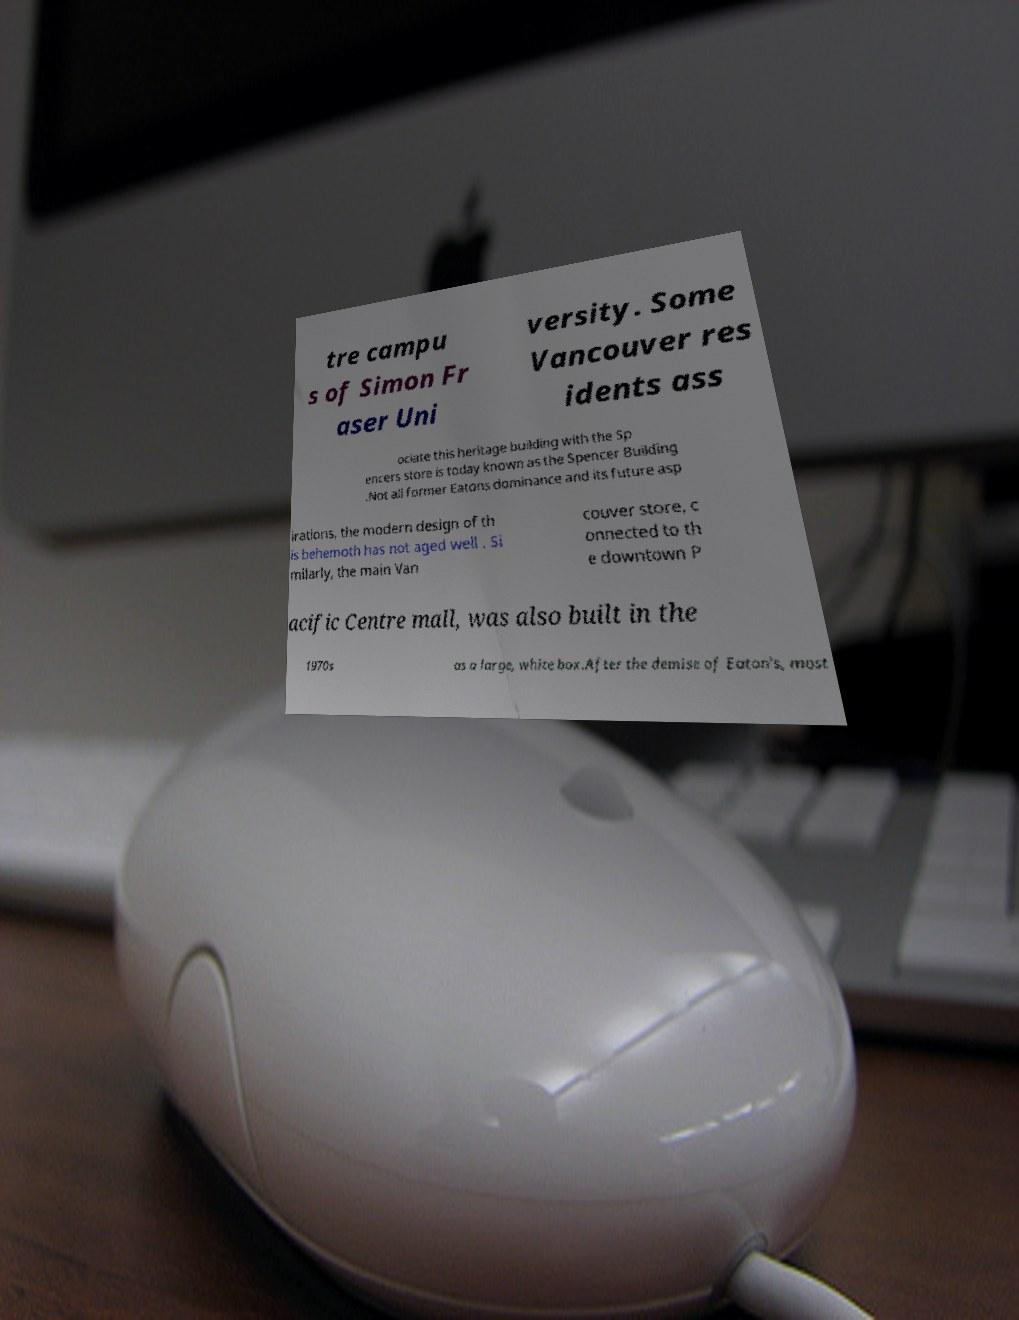What messages or text are displayed in this image? I need them in a readable, typed format. tre campu s of Simon Fr aser Uni versity. Some Vancouver res idents ass ociate this heritage building with the Sp encers store is today known as the Spencer Building .Not all former Eatons dominance and its future asp irations, the modern design of th is behemoth has not aged well . Si milarly, the main Van couver store, c onnected to th e downtown P acific Centre mall, was also built in the 1970s as a large, white box.After the demise of Eaton's, most 